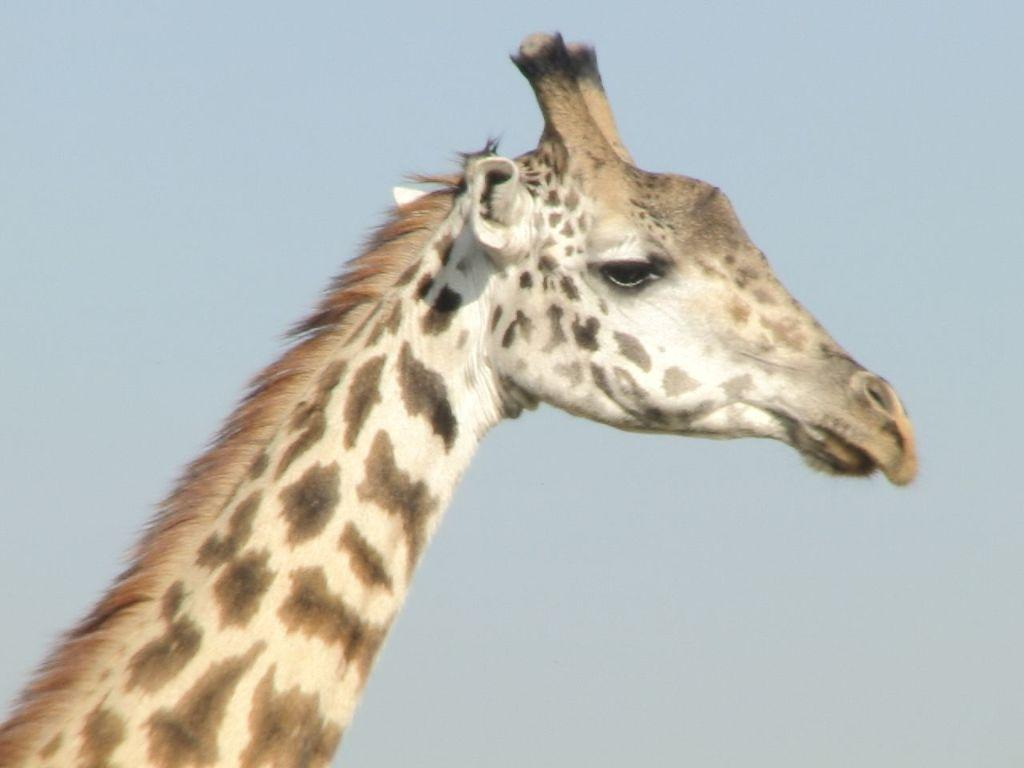What animal is present in the image? There is a giraffe in the image. What can be seen in the background of the image? The sky is visible in the background of the image. What type of coil is being used by the giraffe in the image? There is no coil present in the image, as it features a giraffe and the sky. What flavor of ice cream is the giraffe enjoying in the image? There is no ice cream present in the image, so it cannot be determined if the giraffe is enjoying any flavor. 